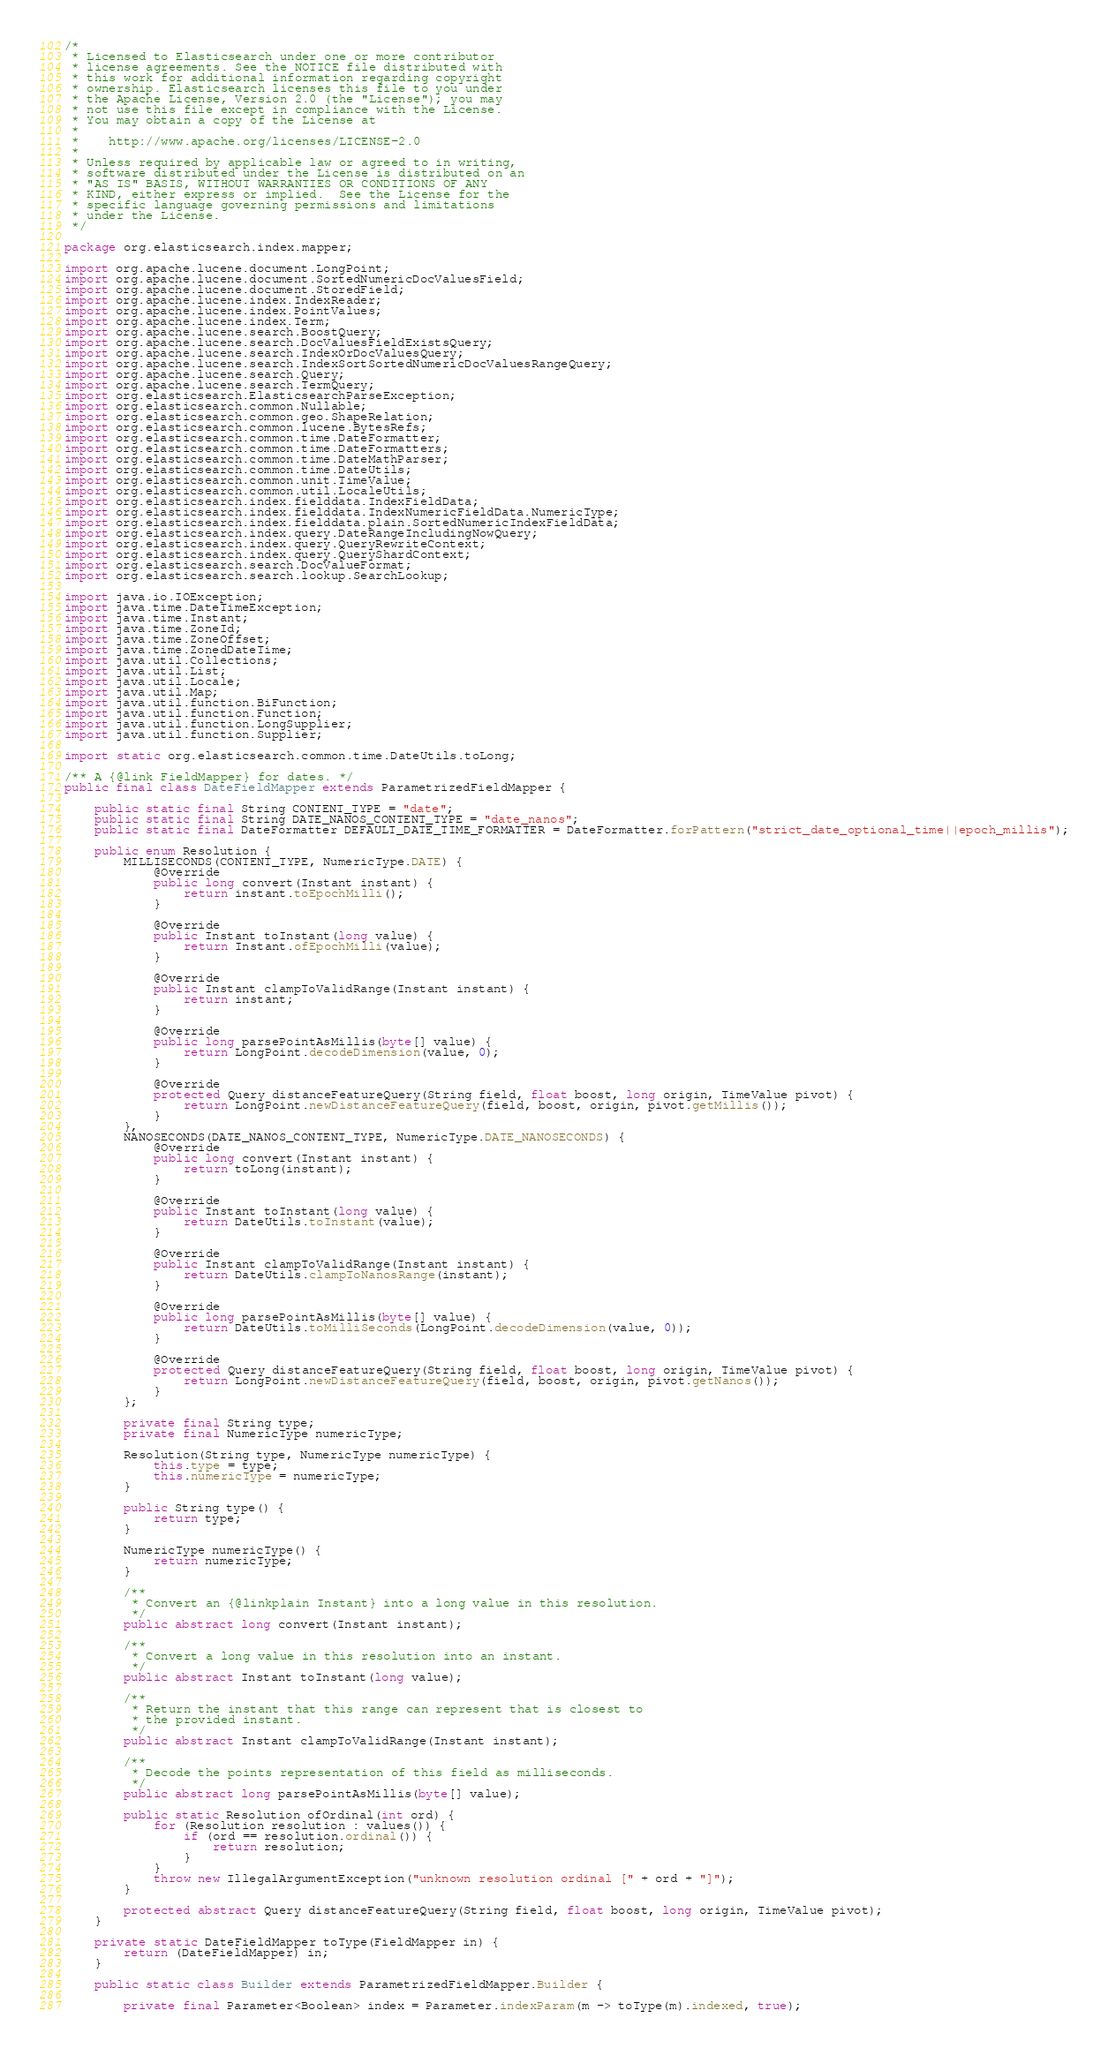Convert code to text. <code><loc_0><loc_0><loc_500><loc_500><_Java_>/*
 * Licensed to Elasticsearch under one or more contributor
 * license agreements. See the NOTICE file distributed with
 * this work for additional information regarding copyright
 * ownership. Elasticsearch licenses this file to you under
 * the Apache License, Version 2.0 (the "License"); you may
 * not use this file except in compliance with the License.
 * You may obtain a copy of the License at
 *
 *    http://www.apache.org/licenses/LICENSE-2.0
 *
 * Unless required by applicable law or agreed to in writing,
 * software distributed under the License is distributed on an
 * "AS IS" BASIS, WITHOUT WARRANTIES OR CONDITIONS OF ANY
 * KIND, either express or implied.  See the License for the
 * specific language governing permissions and limitations
 * under the License.
 */

package org.elasticsearch.index.mapper;

import org.apache.lucene.document.LongPoint;
import org.apache.lucene.document.SortedNumericDocValuesField;
import org.apache.lucene.document.StoredField;
import org.apache.lucene.index.IndexReader;
import org.apache.lucene.index.PointValues;
import org.apache.lucene.index.Term;
import org.apache.lucene.search.BoostQuery;
import org.apache.lucene.search.DocValuesFieldExistsQuery;
import org.apache.lucene.search.IndexOrDocValuesQuery;
import org.apache.lucene.search.IndexSortSortedNumericDocValuesRangeQuery;
import org.apache.lucene.search.Query;
import org.apache.lucene.search.TermQuery;
import org.elasticsearch.ElasticsearchParseException;
import org.elasticsearch.common.Nullable;
import org.elasticsearch.common.geo.ShapeRelation;
import org.elasticsearch.common.lucene.BytesRefs;
import org.elasticsearch.common.time.DateFormatter;
import org.elasticsearch.common.time.DateFormatters;
import org.elasticsearch.common.time.DateMathParser;
import org.elasticsearch.common.time.DateUtils;
import org.elasticsearch.common.unit.TimeValue;
import org.elasticsearch.common.util.LocaleUtils;
import org.elasticsearch.index.fielddata.IndexFieldData;
import org.elasticsearch.index.fielddata.IndexNumericFieldData.NumericType;
import org.elasticsearch.index.fielddata.plain.SortedNumericIndexFieldData;
import org.elasticsearch.index.query.DateRangeIncludingNowQuery;
import org.elasticsearch.index.query.QueryRewriteContext;
import org.elasticsearch.index.query.QueryShardContext;
import org.elasticsearch.search.DocValueFormat;
import org.elasticsearch.search.lookup.SearchLookup;

import java.io.IOException;
import java.time.DateTimeException;
import java.time.Instant;
import java.time.ZoneId;
import java.time.ZoneOffset;
import java.time.ZonedDateTime;
import java.util.Collections;
import java.util.List;
import java.util.Locale;
import java.util.Map;
import java.util.function.BiFunction;
import java.util.function.Function;
import java.util.function.LongSupplier;
import java.util.function.Supplier;

import static org.elasticsearch.common.time.DateUtils.toLong;

/** A {@link FieldMapper} for dates. */
public final class DateFieldMapper extends ParametrizedFieldMapper {

    public static final String CONTENT_TYPE = "date";
    public static final String DATE_NANOS_CONTENT_TYPE = "date_nanos";
    public static final DateFormatter DEFAULT_DATE_TIME_FORMATTER = DateFormatter.forPattern("strict_date_optional_time||epoch_millis");

    public enum Resolution {
        MILLISECONDS(CONTENT_TYPE, NumericType.DATE) {
            @Override
            public long convert(Instant instant) {
                return instant.toEpochMilli();
            }

            @Override
            public Instant toInstant(long value) {
                return Instant.ofEpochMilli(value);
            }

            @Override
            public Instant clampToValidRange(Instant instant) {
                return instant;
            }

            @Override
            public long parsePointAsMillis(byte[] value) {
                return LongPoint.decodeDimension(value, 0);
            }

            @Override
            protected Query distanceFeatureQuery(String field, float boost, long origin, TimeValue pivot) {
                return LongPoint.newDistanceFeatureQuery(field, boost, origin, pivot.getMillis());
            }
        },
        NANOSECONDS(DATE_NANOS_CONTENT_TYPE, NumericType.DATE_NANOSECONDS) {
            @Override
            public long convert(Instant instant) {
                return toLong(instant);
            }

            @Override
            public Instant toInstant(long value) {
                return DateUtils.toInstant(value);
            }

            @Override
            public Instant clampToValidRange(Instant instant) {
                return DateUtils.clampToNanosRange(instant);
            }

            @Override
            public long parsePointAsMillis(byte[] value) {
                return DateUtils.toMilliSeconds(LongPoint.decodeDimension(value, 0));
            }

            @Override
            protected Query distanceFeatureQuery(String field, float boost, long origin, TimeValue pivot) {
                return LongPoint.newDistanceFeatureQuery(field, boost, origin, pivot.getNanos());
            }
        };

        private final String type;
        private final NumericType numericType;

        Resolution(String type, NumericType numericType) {
            this.type = type;
            this.numericType = numericType;
        }

        public String type() {
            return type;
        }

        NumericType numericType() {
            return numericType;
        }

        /**
         * Convert an {@linkplain Instant} into a long value in this resolution.
         */
        public abstract long convert(Instant instant);

        /**
         * Convert a long value in this resolution into an instant.
         */
        public abstract Instant toInstant(long value);

        /**
         * Return the instant that this range can represent that is closest to
         * the provided instant.
         */
        public abstract Instant clampToValidRange(Instant instant);

        /**
         * Decode the points representation of this field as milliseconds.
         */
        public abstract long parsePointAsMillis(byte[] value);

        public static Resolution ofOrdinal(int ord) {
            for (Resolution resolution : values()) {
                if (ord == resolution.ordinal()) {
                    return resolution;
                }
            }
            throw new IllegalArgumentException("unknown resolution ordinal [" + ord + "]");
        }

        protected abstract Query distanceFeatureQuery(String field, float boost, long origin, TimeValue pivot);
    }

    private static DateFieldMapper toType(FieldMapper in) {
        return (DateFieldMapper) in;
    }

    public static class Builder extends ParametrizedFieldMapper.Builder {

        private final Parameter<Boolean> index = Parameter.indexParam(m -> toType(m).indexed, true);</code> 